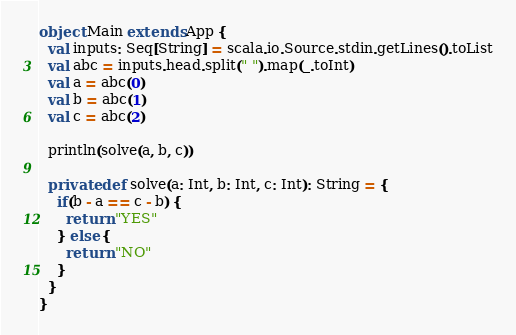Convert code to text. <code><loc_0><loc_0><loc_500><loc_500><_Scala_>object Main extends App {
  val inputs: Seq[String] = scala.io.Source.stdin.getLines().toList
  val abc = inputs.head.split(" ").map(_.toInt)
  val a = abc(0)
  val b = abc(1)
  val c = abc(2)

  println(solve(a, b, c))

  private def solve(a: Int, b: Int, c: Int): String = {
    if(b - a == c - b) {
      return "YES"
    } else {
      return "NO"
    }
  }
}</code> 